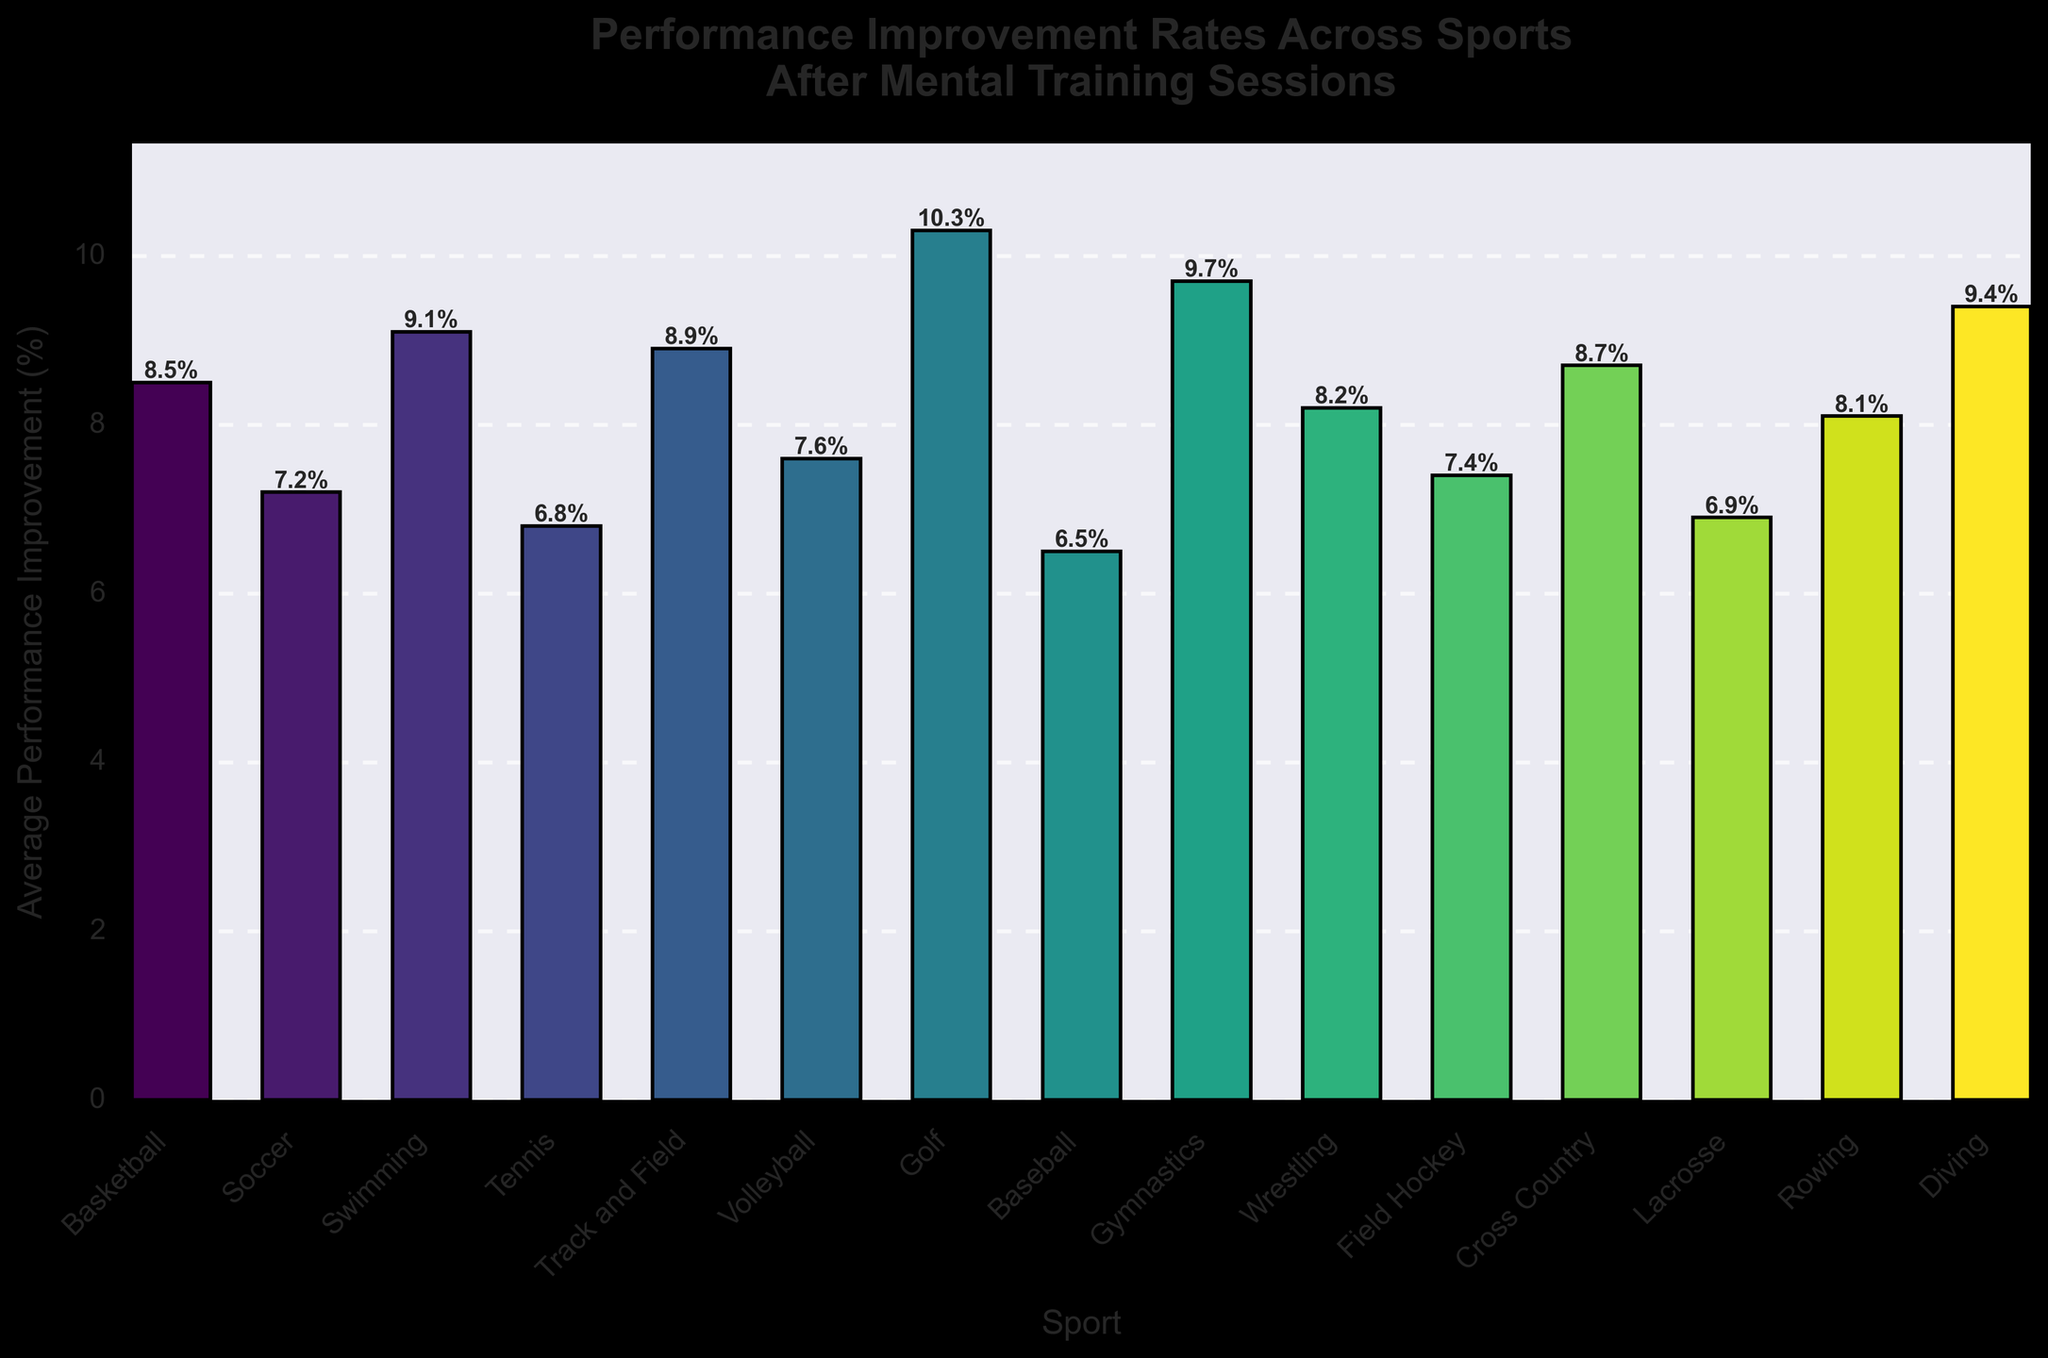Which sport shows the highest average performance improvement? Look at the bar with the maximum height, which corresponds to Golf. It has the label "10.3%" displayed on it indicating the highest improvement rate.
Answer: Golf Which two sports have the lowest performance improvements? Identify the two shortest bars in the chart. These are Tennis (6.8%) and Baseball (6.5%).
Answer: Tennis and Baseball What is the average improvement rate across all listed sports? Sum up the performance improvements of all sports and divide by the number of sports. (8.5 + 7.2 + 9.1 + 6.8 + 8.9 + 7.6 + 10.3 + 6.5 + 9.7 + 8.2 + 7.4 + 8.7 + 6.9 + 8.1 + 9.4) / 15 = 126.3 / 15
Answer: 8.4% How does the performance improvement in Swimming compare to Volleyball? Compare the heights of the bars for Swimming (9.1%) and Volleyball (7.6%). Swimming has a higher improvement rate than Volleyball.
Answer: Swimming has a higher improvement rate than Volleyball What is the total performance improvement percentage for Gymnastics and Diving combined? Add up the performance improvement rates of Gymnastics (9.7%) and Diving (9.4%). 9.7 + 9.4 = 19.1%
Answer: 19.1% Which sport, between Cross Country and Wrestling, has a higher performance improvement rate? Compare the bars for Cross Country (8.7%) and Wrestling (8.2%). Cross Country's bar is slightly higher.
Answer: Cross Country Are there more sports with performance improvements above or below 8%? Count the number of bars above and below 8%. Above 8%: Basketball, Swimming, Track and Field, Golf, Gymnastics, Cross Country, and Diving (7 sports). Below 8%: Soccer, Tennis, Volleyball, Baseball, Field Hockey, Lacrosse, Rowing, and Wrestling (8 sports).
Answer: Below 8% Which sport's performance improvement rate is closest to the overall average of 8.4%? Compare the performance improvement rates of each sport to 8.4%. Wrestling (8.2%) is the closest to 8.4%.
Answer: Wrestling What is the difference in performance improvement rates between the sport with the highest and the sport with the lowest improvement rate? Subtract the smallest improvement rate (Baseball, 6.5%) from the largest improvement rate (Golf, 10.3%). 10.3 - 6.5 = 3.8%
Answer: 3.8% 